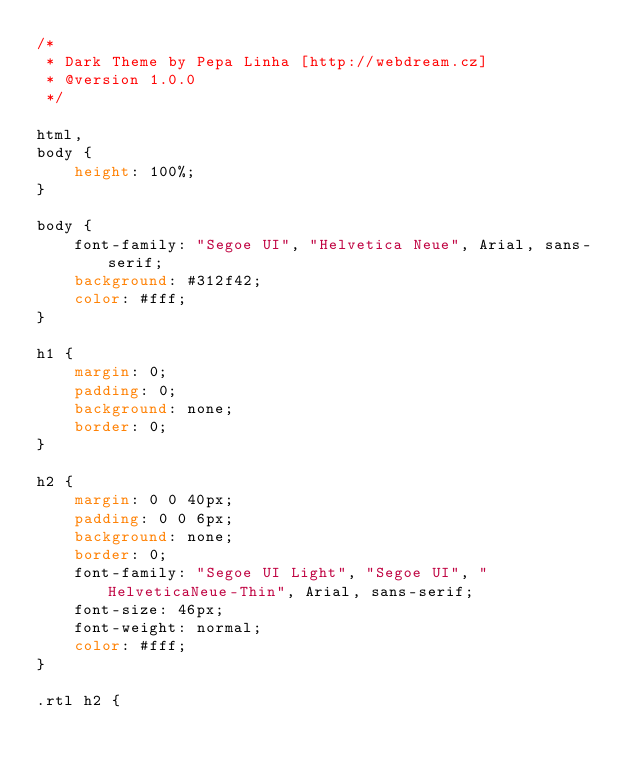<code> <loc_0><loc_0><loc_500><loc_500><_CSS_>/*
 * Dark Theme by Pepa Linha [http://webdream.cz]
 * @version 1.0.0
 */

html,
body {
    height: 100%;
}

body {
    font-family: "Segoe UI", "Helvetica Neue", Arial, sans-serif;
    background: #312f42;
    color: #fff;
}

h1 {
    margin: 0;
    padding: 0;
    background: none;
    border: 0;
}

h2 {
    margin: 0 0 40px;
    padding: 0 0 6px;
    background: none;
    border: 0;
    font-family: "Segoe UI Light", "Segoe UI", "HelveticaNeue-Thin", Arial, sans-serif;
    font-size: 46px;
    font-weight: normal;
    color: #fff;
}

.rtl h2 {</code> 